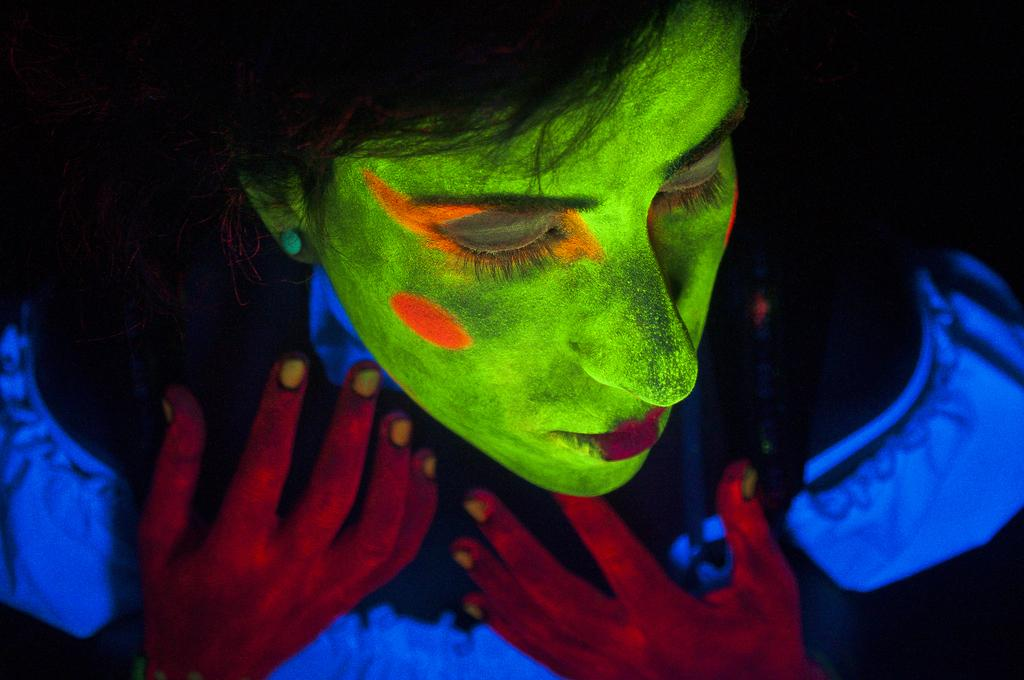What is the main subject of the image? There is a person in the image. Can you describe the person's appearance? The person is wearing black light face painting. What type of rail can be seen in the image? There is no rail present in the image; it features a person with black light face painting. What scientific theory is being discussed in the image? There is no discussion of a scientific theory in the image; it focuses on the person's appearance with black light face painting. 